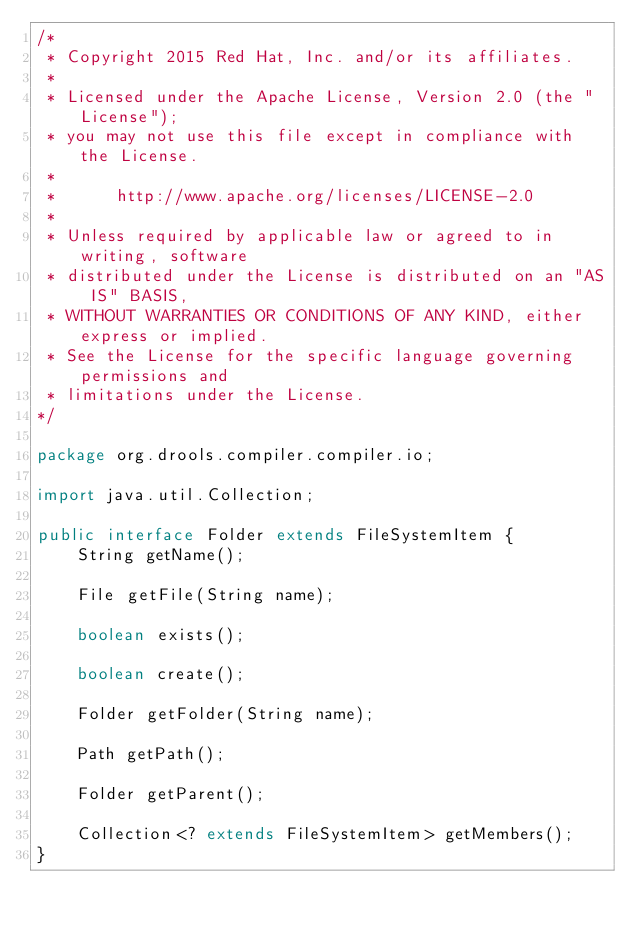<code> <loc_0><loc_0><loc_500><loc_500><_Java_>/*
 * Copyright 2015 Red Hat, Inc. and/or its affiliates.
 *
 * Licensed under the Apache License, Version 2.0 (the "License");
 * you may not use this file except in compliance with the License.
 * 
 *      http://www.apache.org/licenses/LICENSE-2.0
 *
 * Unless required by applicable law or agreed to in writing, software
 * distributed under the License is distributed on an "AS IS" BASIS,
 * WITHOUT WARRANTIES OR CONDITIONS OF ANY KIND, either express or implied.
 * See the License for the specific language governing permissions and
 * limitations under the License.
*/

package org.drools.compiler.compiler.io;

import java.util.Collection;

public interface Folder extends FileSystemItem {
    String getName();
    
    File getFile(String name);
    
    boolean exists();
    
    boolean create();
    
    Folder getFolder(String name);
    
    Path getPath();
    
    Folder getParent();
    
    Collection<? extends FileSystemItem> getMembers();
}
</code> 